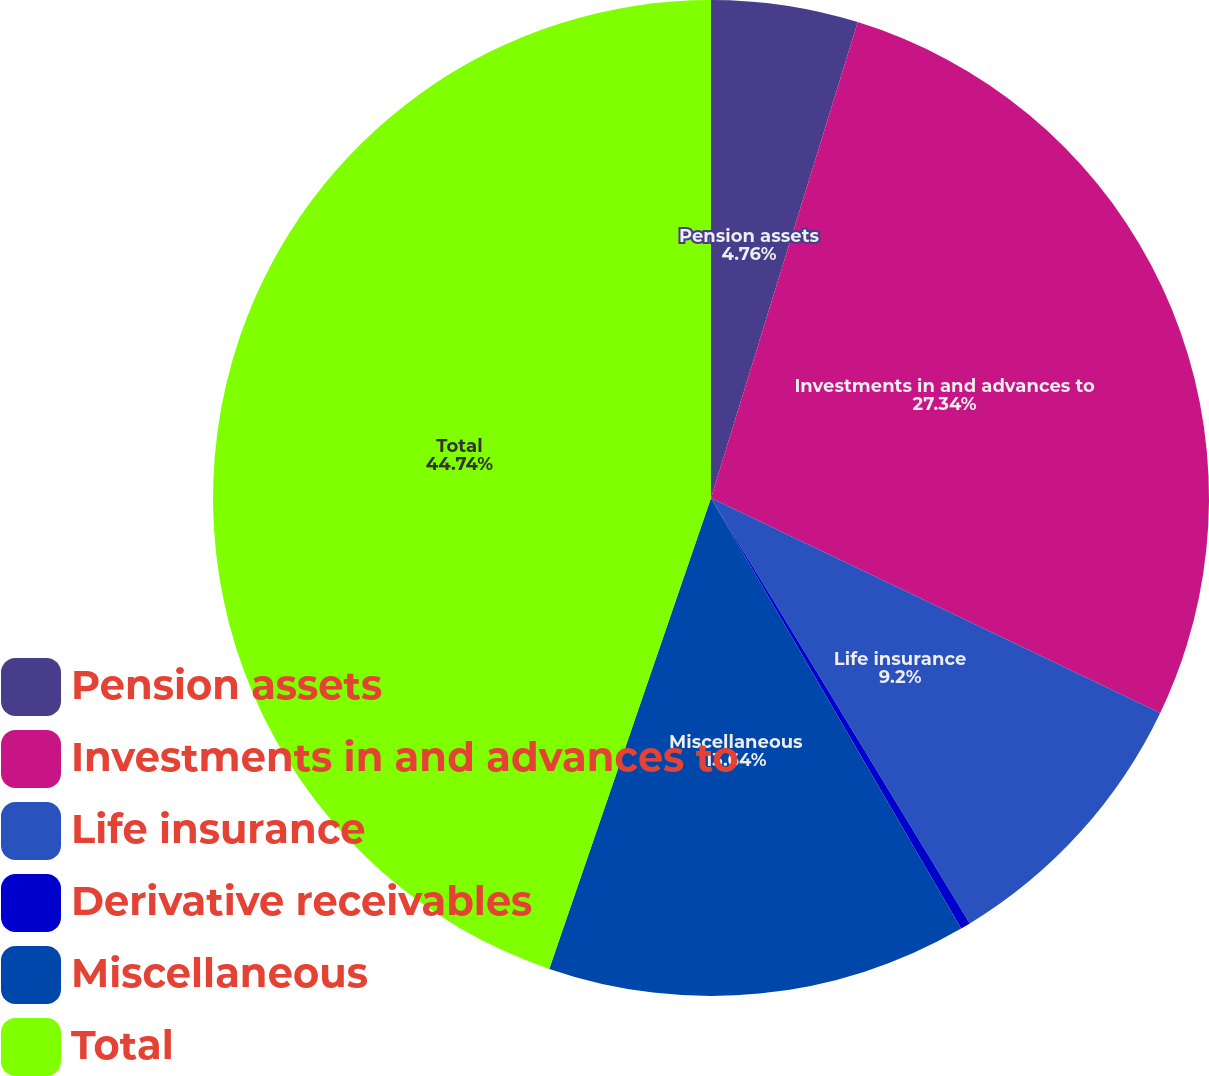Convert chart to OTSL. <chart><loc_0><loc_0><loc_500><loc_500><pie_chart><fcel>Pension assets<fcel>Investments in and advances to<fcel>Life insurance<fcel>Derivative receivables<fcel>Miscellaneous<fcel>Total<nl><fcel>4.76%<fcel>27.34%<fcel>9.2%<fcel>0.32%<fcel>13.64%<fcel>44.73%<nl></chart> 